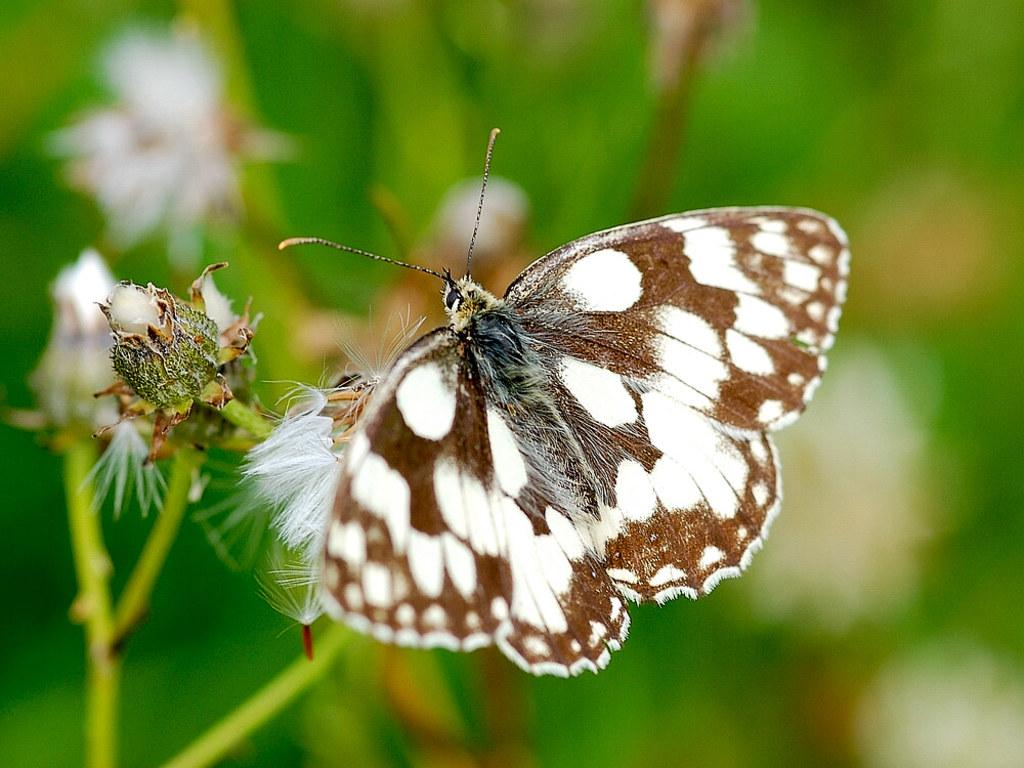What is the main subject of the image? There is a butterfly in the image. Where is the butterfly located? The butterfly is on a flower. Can you describe the background of the image? The background of the image is blurred. How does the butterfly use the umbrella in the image? There is no umbrella present in the image, so the butterfly cannot use one. 